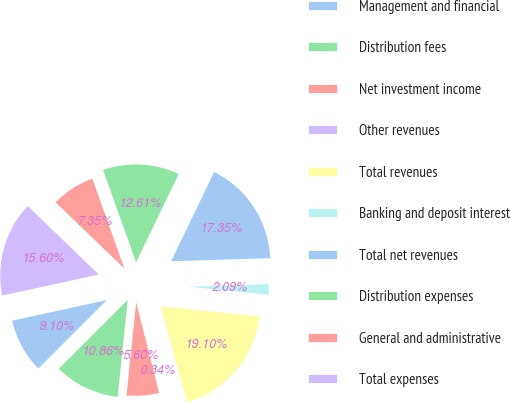<chart> <loc_0><loc_0><loc_500><loc_500><pie_chart><fcel>Management and financial<fcel>Distribution fees<fcel>Net investment income<fcel>Other revenues<fcel>Total revenues<fcel>Banking and deposit interest<fcel>Total net revenues<fcel>Distribution expenses<fcel>General and administrative<fcel>Total expenses<nl><fcel>9.1%<fcel>10.86%<fcel>5.6%<fcel>0.34%<fcel>19.1%<fcel>2.09%<fcel>17.35%<fcel>12.61%<fcel>7.35%<fcel>15.6%<nl></chart> 